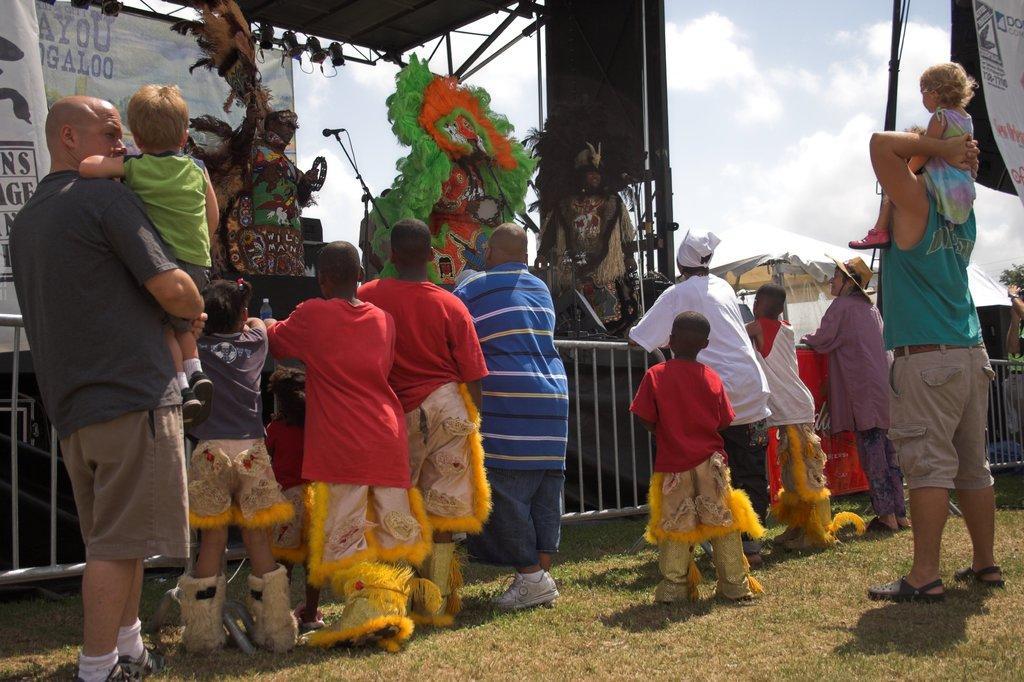Could you give a brief overview of what you see in this image? There are few people standing. These are the barricades. I can see three people standing on the stage. They wore fancy dresses. This is a mike attached to the mike stand. At the top of the image, I can see the show lights. This looks like a banner. This is the grass. I can see the sky. This is a kind of a patio umbrella. 